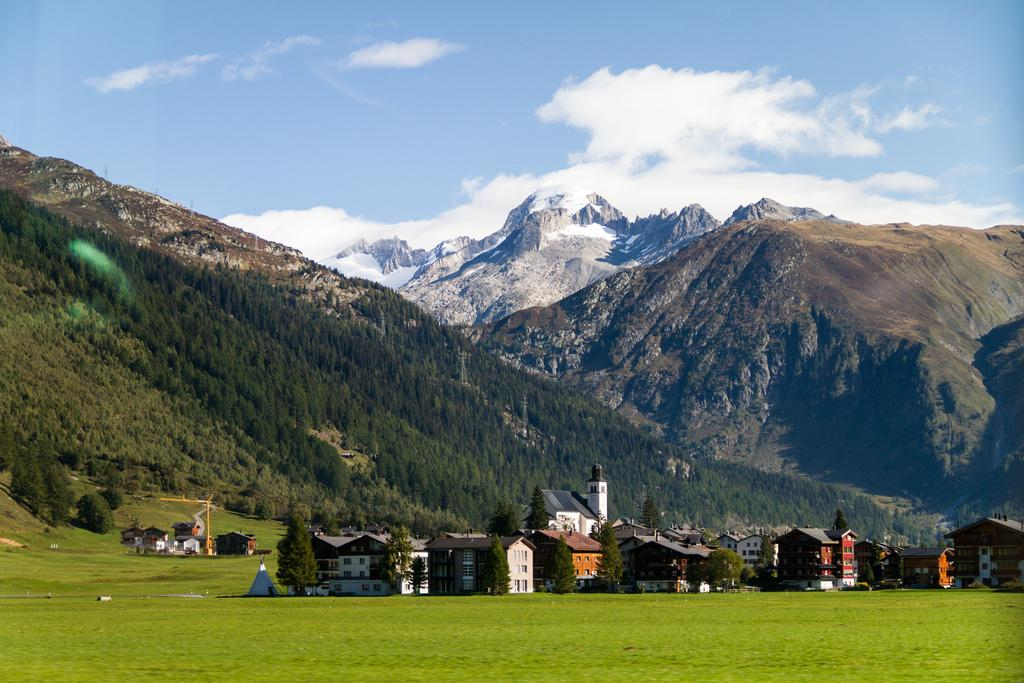What colors are used for the buildings in the image? The buildings in the image are in brown and cream color. What type of vegetation can be seen in the background of the image? There are trees in green color in the background of the image. What natural feature is visible in the background of the image? There are mountains visible in the background of the image. What colors are used for the sky in the image? The sky is in blue and white color in the image. What type of sweater is being worn by the jelly in the image? There is no jelly or sweater present in the image. How many heads are visible in the image? There are no heads visible in the image; it features buildings, trees, mountains, and the sky. 